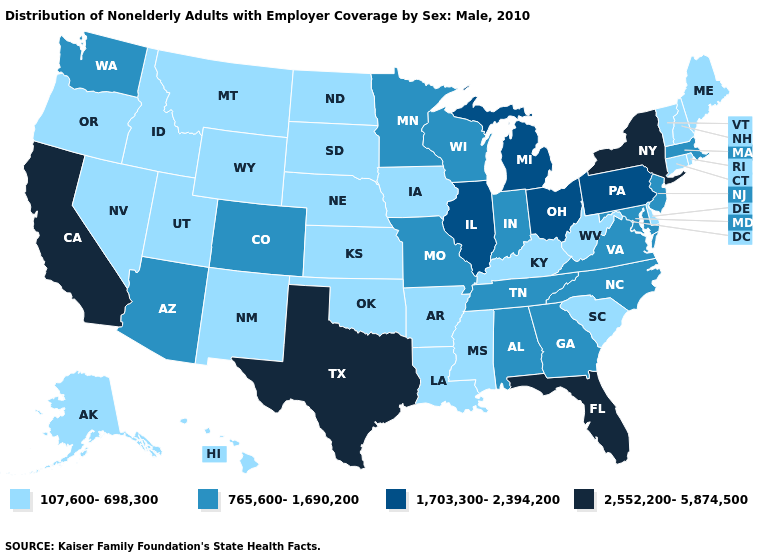What is the lowest value in states that border Iowa?
Answer briefly. 107,600-698,300. Name the states that have a value in the range 765,600-1,690,200?
Concise answer only. Alabama, Arizona, Colorado, Georgia, Indiana, Maryland, Massachusetts, Minnesota, Missouri, New Jersey, North Carolina, Tennessee, Virginia, Washington, Wisconsin. What is the value of Georgia?
Concise answer only. 765,600-1,690,200. What is the lowest value in the USA?
Write a very short answer. 107,600-698,300. Name the states that have a value in the range 765,600-1,690,200?
Answer briefly. Alabama, Arizona, Colorado, Georgia, Indiana, Maryland, Massachusetts, Minnesota, Missouri, New Jersey, North Carolina, Tennessee, Virginia, Washington, Wisconsin. What is the value of Idaho?
Quick response, please. 107,600-698,300. Is the legend a continuous bar?
Keep it brief. No. Name the states that have a value in the range 765,600-1,690,200?
Write a very short answer. Alabama, Arizona, Colorado, Georgia, Indiana, Maryland, Massachusetts, Minnesota, Missouri, New Jersey, North Carolina, Tennessee, Virginia, Washington, Wisconsin. Does Alabama have a higher value than Mississippi?
Concise answer only. Yes. Name the states that have a value in the range 107,600-698,300?
Give a very brief answer. Alaska, Arkansas, Connecticut, Delaware, Hawaii, Idaho, Iowa, Kansas, Kentucky, Louisiana, Maine, Mississippi, Montana, Nebraska, Nevada, New Hampshire, New Mexico, North Dakota, Oklahoma, Oregon, Rhode Island, South Carolina, South Dakota, Utah, Vermont, West Virginia, Wyoming. What is the value of West Virginia?
Short answer required. 107,600-698,300. Does California have the highest value in the West?
Answer briefly. Yes. Is the legend a continuous bar?
Short answer required. No. What is the value of South Dakota?
Give a very brief answer. 107,600-698,300. Name the states that have a value in the range 1,703,300-2,394,200?
Quick response, please. Illinois, Michigan, Ohio, Pennsylvania. 